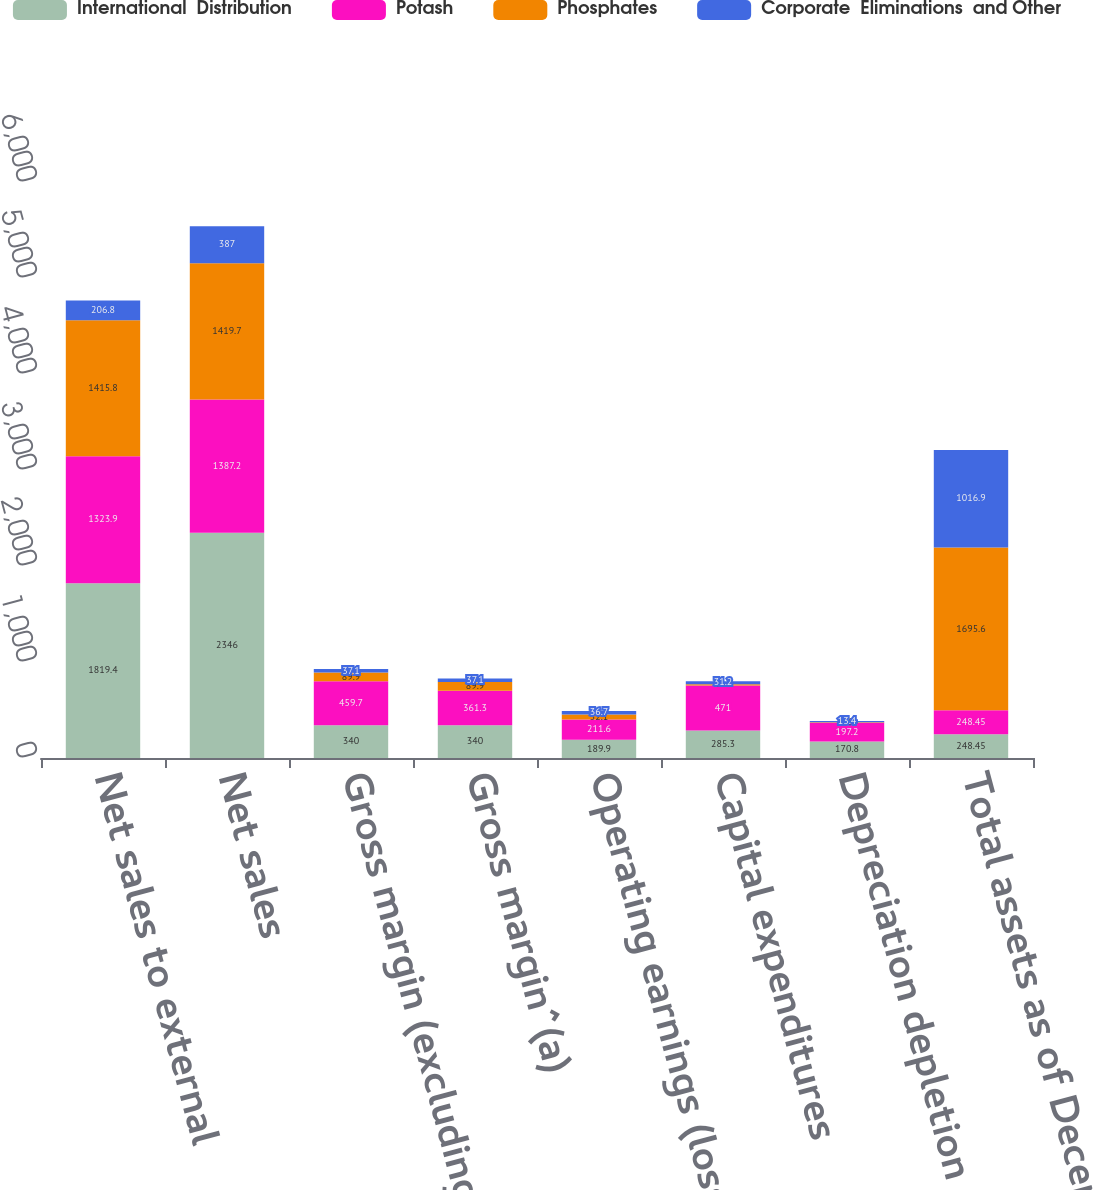<chart> <loc_0><loc_0><loc_500><loc_500><stacked_bar_chart><ecel><fcel>Net sales to external<fcel>Net sales<fcel>Gross margin (excluding<fcel>Gross margin^(a)<fcel>Operating earnings (loss)<fcel>Capital expenditures<fcel>Depreciation depletion and<fcel>Total assets as of December 31<nl><fcel>International  Distribution<fcel>1819.4<fcel>2346<fcel>340<fcel>340<fcel>189.9<fcel>285.3<fcel>170.8<fcel>248.45<nl><fcel>Potash<fcel>1323.9<fcel>1387.2<fcel>459.7<fcel>361.3<fcel>211.6<fcel>471<fcel>197.2<fcel>248.45<nl><fcel>Phosphates<fcel>1415.8<fcel>1419.7<fcel>89.9<fcel>89.9<fcel>52.1<fcel>12.5<fcel>4.8<fcel>1695.6<nl><fcel>Corporate  Eliminations  and Other<fcel>206.8<fcel>387<fcel>37.1<fcel>37.1<fcel>36.7<fcel>31.2<fcel>13.4<fcel>1016.9<nl></chart> 